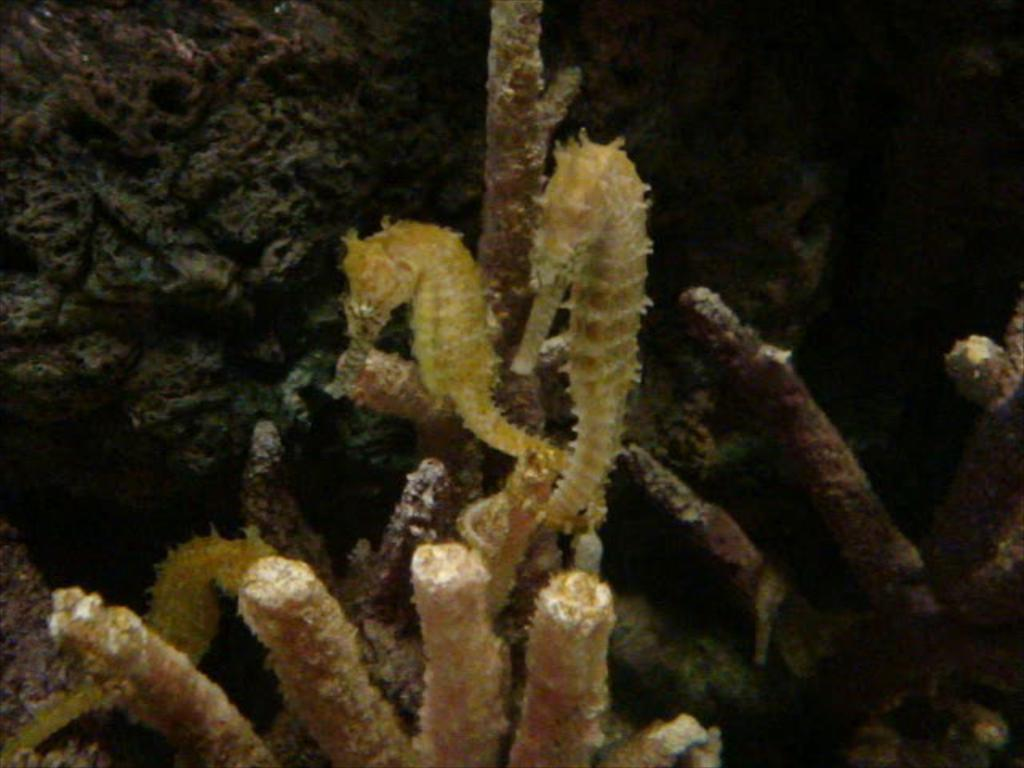What type of marine animals are present in the image? There are sea horses in the image. What other objects or features can be seen in the image? There are corals in the image. How would you describe the lighting or brightness in the image? The view in the image is dark. What type of precipitation can be seen falling in the image? There is no precipitation present in the image; it features sea horses and corals in a dark environment. 